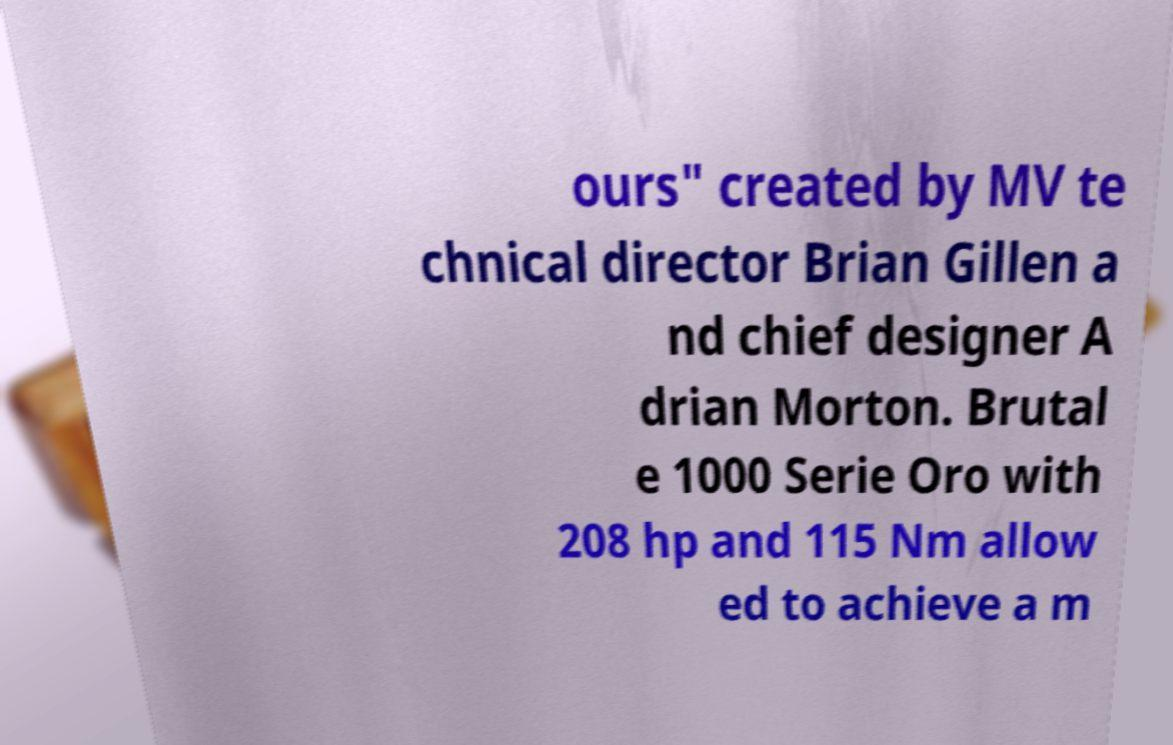Could you extract and type out the text from this image? ours" created by MV te chnical director Brian Gillen a nd chief designer A drian Morton. Brutal e 1000 Serie Oro with 208 hp and 115 Nm allow ed to achieve a m 